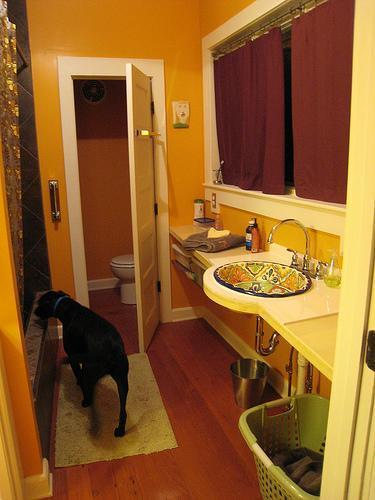How many dogs are there?
Give a very brief answer. 1. 